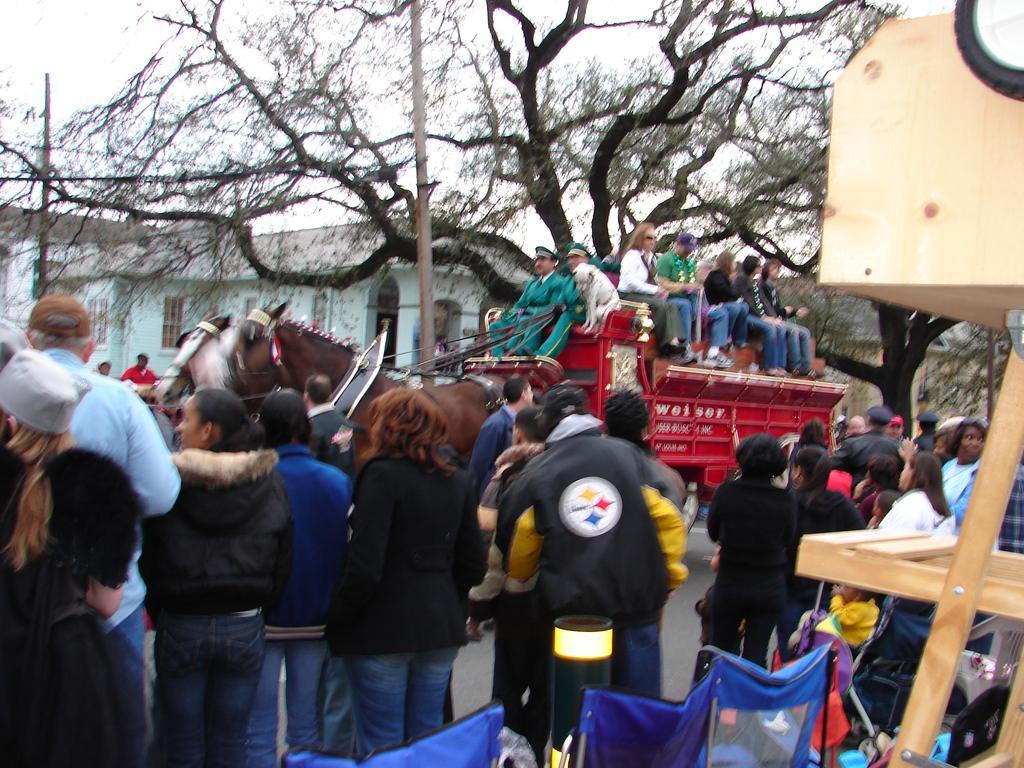Can you describe this image briefly? In this image we can see few persons are standing and few persons are riding on the horse cart on the road. On the right side we can see a wooden stand and bags. In the background there are trees, buildings, windows and sky. 